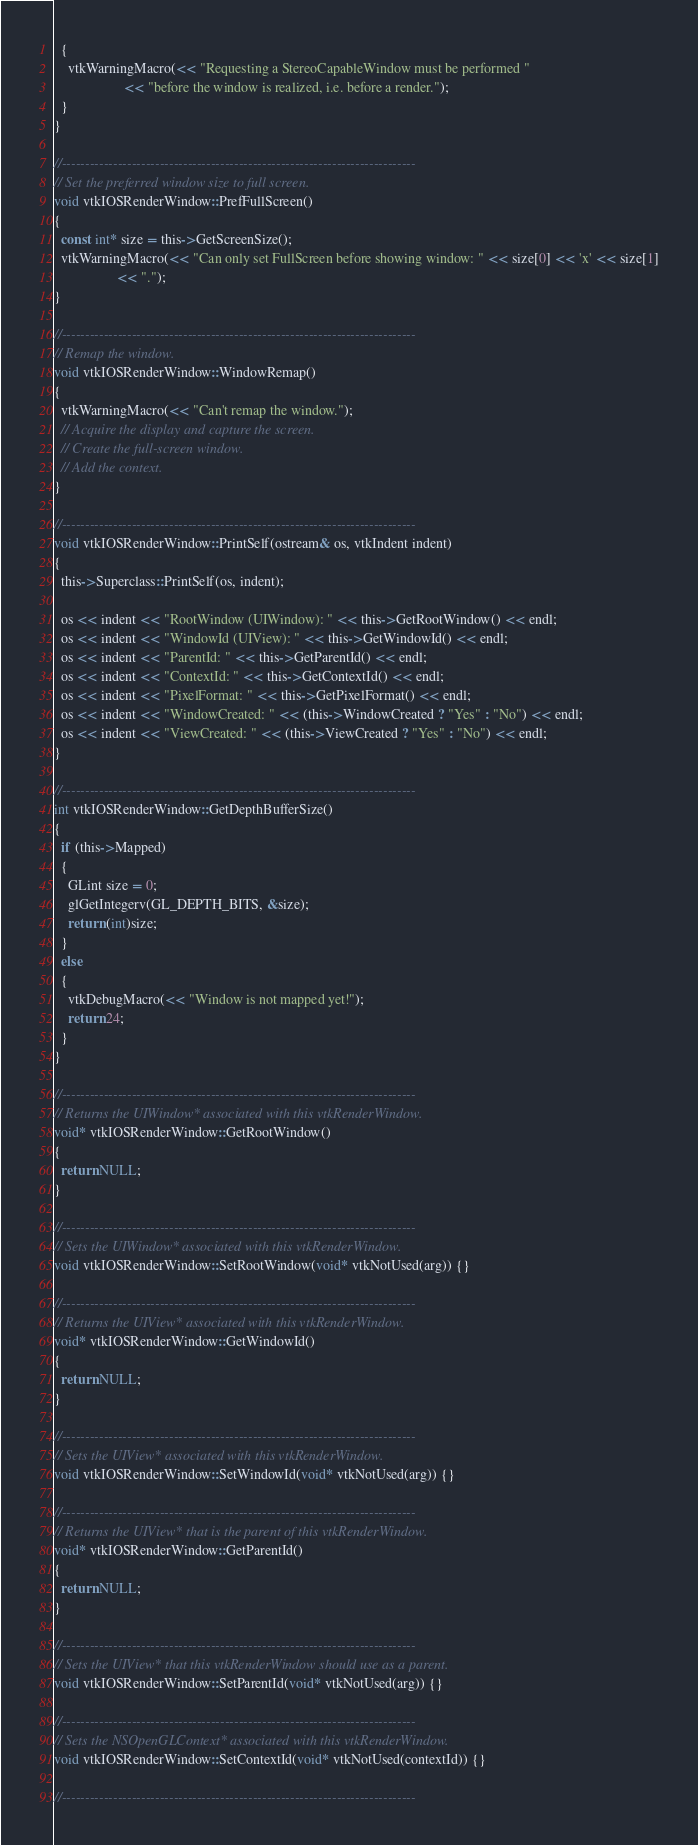<code> <loc_0><loc_0><loc_500><loc_500><_ObjectiveC_>  {
    vtkWarningMacro(<< "Requesting a StereoCapableWindow must be performed "
                    << "before the window is realized, i.e. before a render.");
  }
}

//----------------------------------------------------------------------------
// Set the preferred window size to full screen.
void vtkIOSRenderWindow::PrefFullScreen()
{
  const int* size = this->GetScreenSize();
  vtkWarningMacro(<< "Can only set FullScreen before showing window: " << size[0] << 'x' << size[1]
                  << ".");
}

//----------------------------------------------------------------------------
// Remap the window.
void vtkIOSRenderWindow::WindowRemap()
{
  vtkWarningMacro(<< "Can't remap the window.");
  // Acquire the display and capture the screen.
  // Create the full-screen window.
  // Add the context.
}

//----------------------------------------------------------------------------
void vtkIOSRenderWindow::PrintSelf(ostream& os, vtkIndent indent)
{
  this->Superclass::PrintSelf(os, indent);

  os << indent << "RootWindow (UIWindow): " << this->GetRootWindow() << endl;
  os << indent << "WindowId (UIView): " << this->GetWindowId() << endl;
  os << indent << "ParentId: " << this->GetParentId() << endl;
  os << indent << "ContextId: " << this->GetContextId() << endl;
  os << indent << "PixelFormat: " << this->GetPixelFormat() << endl;
  os << indent << "WindowCreated: " << (this->WindowCreated ? "Yes" : "No") << endl;
  os << indent << "ViewCreated: " << (this->ViewCreated ? "Yes" : "No") << endl;
}

//----------------------------------------------------------------------------
int vtkIOSRenderWindow::GetDepthBufferSize()
{
  if (this->Mapped)
  {
    GLint size = 0;
    glGetIntegerv(GL_DEPTH_BITS, &size);
    return (int)size;
  }
  else
  {
    vtkDebugMacro(<< "Window is not mapped yet!");
    return 24;
  }
}

//----------------------------------------------------------------------------
// Returns the UIWindow* associated with this vtkRenderWindow.
void* vtkIOSRenderWindow::GetRootWindow()
{
  return NULL;
}

//----------------------------------------------------------------------------
// Sets the UIWindow* associated with this vtkRenderWindow.
void vtkIOSRenderWindow::SetRootWindow(void* vtkNotUsed(arg)) {}

//----------------------------------------------------------------------------
// Returns the UIView* associated with this vtkRenderWindow.
void* vtkIOSRenderWindow::GetWindowId()
{
  return NULL;
}

//----------------------------------------------------------------------------
// Sets the UIView* associated with this vtkRenderWindow.
void vtkIOSRenderWindow::SetWindowId(void* vtkNotUsed(arg)) {}

//----------------------------------------------------------------------------
// Returns the UIView* that is the parent of this vtkRenderWindow.
void* vtkIOSRenderWindow::GetParentId()
{
  return NULL;
}

//----------------------------------------------------------------------------
// Sets the UIView* that this vtkRenderWindow should use as a parent.
void vtkIOSRenderWindow::SetParentId(void* vtkNotUsed(arg)) {}

//----------------------------------------------------------------------------
// Sets the NSOpenGLContext* associated with this vtkRenderWindow.
void vtkIOSRenderWindow::SetContextId(void* vtkNotUsed(contextId)) {}

//----------------------------------------------------------------------------</code> 